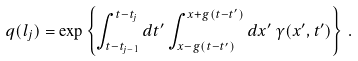<formula> <loc_0><loc_0><loc_500><loc_500>q ( l _ { j } ) = \exp \left \{ \int _ { t - t _ { j - 1 } } ^ { t - t _ { j } } d t ^ { \prime } \int _ { x - g ( t - t ^ { \prime } ) } ^ { x + g ( t - t ^ { \prime } ) } d x ^ { \prime } \, \gamma ( x ^ { \prime } , t ^ { \prime } ) \right \} \, .</formula> 